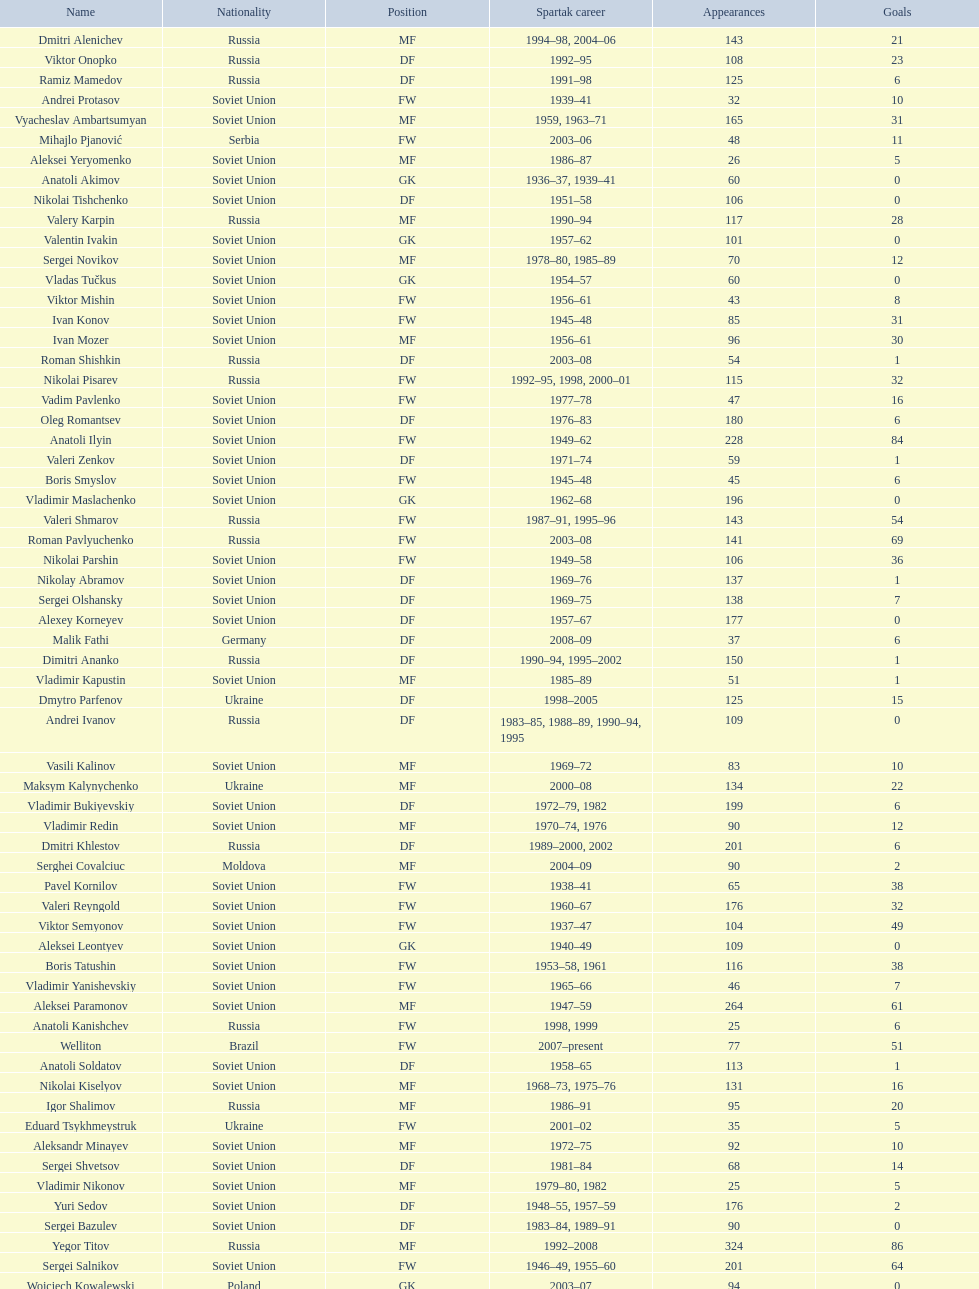Vladimir bukiyevskiy had how many appearances? 199. 